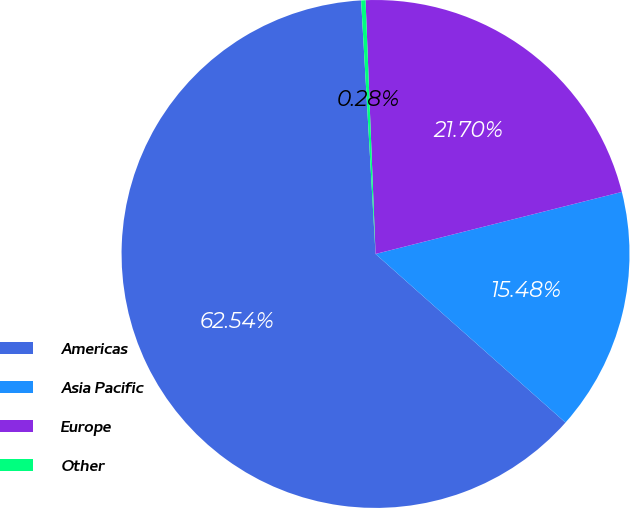Convert chart to OTSL. <chart><loc_0><loc_0><loc_500><loc_500><pie_chart><fcel>Americas<fcel>Asia Pacific<fcel>Europe<fcel>Other<nl><fcel>62.54%<fcel>15.48%<fcel>21.7%<fcel>0.28%<nl></chart> 